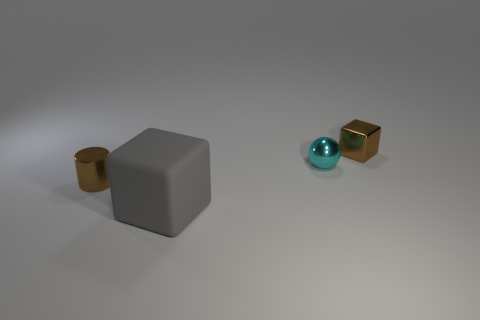Is there anything else that has the same material as the big gray block?
Offer a very short reply. No. Is the tiny ball the same color as the large matte block?
Your response must be concise. No. The brown object on the right side of the tiny brown metallic thing that is left of the brown metal object that is to the right of the big object is what shape?
Offer a terse response. Cube. What is the size of the shiny thing that is both in front of the tiny brown metallic block and on the right side of the cylinder?
Give a very brief answer. Small. Are there fewer cyan spheres than small green metallic cubes?
Your answer should be very brief. No. What is the size of the brown metallic object that is on the left side of the small brown metal cube?
Keep it short and to the point. Small. The object that is both left of the small cyan metallic sphere and right of the cylinder has what shape?
Your answer should be compact. Cube. The other thing that is the same shape as the large gray object is what size?
Your answer should be compact. Small. How many tiny cyan spheres have the same material as the small block?
Make the answer very short. 1. Is the color of the big matte cube the same as the block behind the large gray cube?
Give a very brief answer. No. 